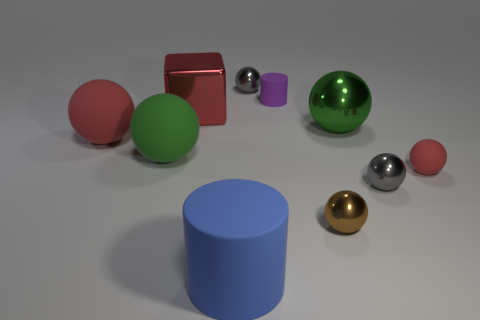Is there any other thing of the same color as the tiny matte cylinder?
Your answer should be very brief. No. There is a large blue thing that is the same material as the tiny purple cylinder; what shape is it?
Ensure brevity in your answer.  Cylinder. There is a large object that is to the right of the big red shiny cube and behind the tiny red rubber object; what is its material?
Make the answer very short. Metal. Is the color of the small cylinder the same as the big cylinder?
Provide a short and direct response. No. The big rubber thing that is the same color as the block is what shape?
Keep it short and to the point. Sphere. How many tiny gray metallic things have the same shape as the large green shiny thing?
Provide a succinct answer. 2. What is the size of the green thing that is made of the same material as the large blue object?
Your answer should be compact. Large. Is the purple cylinder the same size as the green shiny object?
Offer a terse response. No. Are there any big cubes?
Your answer should be very brief. Yes. The rubber object that is the same color as the large metallic sphere is what size?
Provide a short and direct response. Large. 